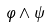Convert formula to latex. <formula><loc_0><loc_0><loc_500><loc_500>\varphi \wedge \psi</formula> 